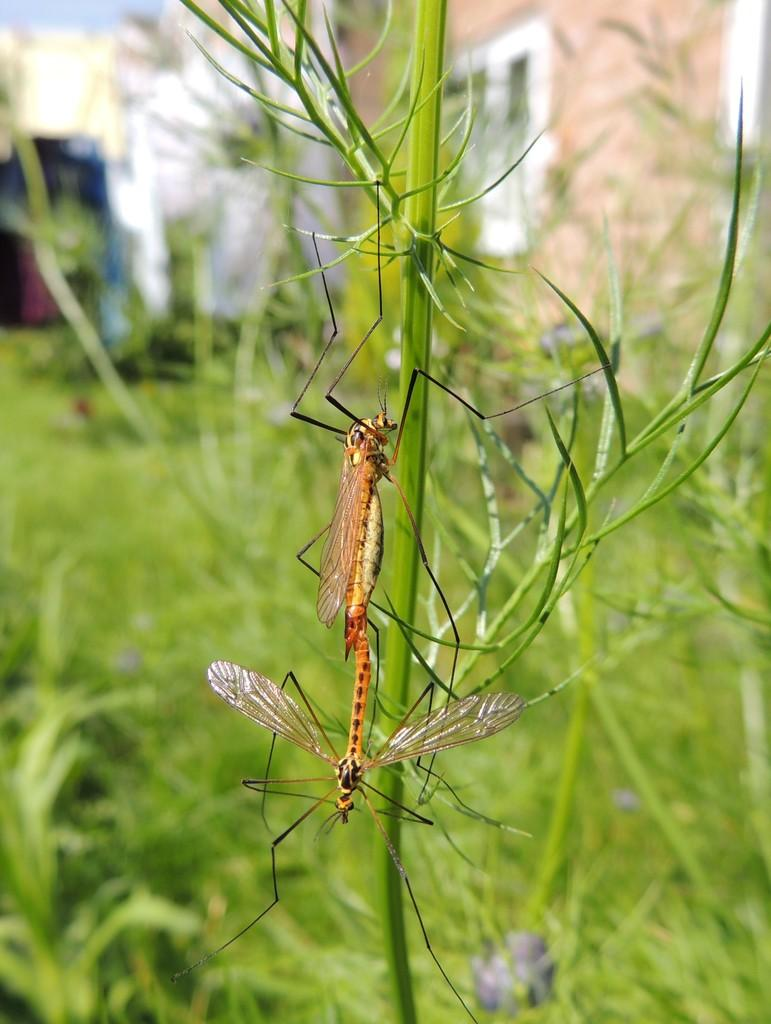How many insects are present in the image? There are two insects in the image. Where are the insects located? The insects are on a plant. Can you describe the background of the image? The background of the image is blurry. What type of vegetation is visible in the background? There is greenery in the background of the image. What expert opinion is provided in the caption of the image? There is no caption or expert opinion present in the image. What type of basket is visible in the image? There is no basket present in the image. 